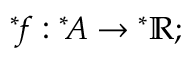<formula> <loc_0><loc_0><loc_500><loc_500>{ ^ { * } \, f } \colon { ^ { * } \, A } \rightarrow { ^ { * } \mathbb { R } } ;</formula> 